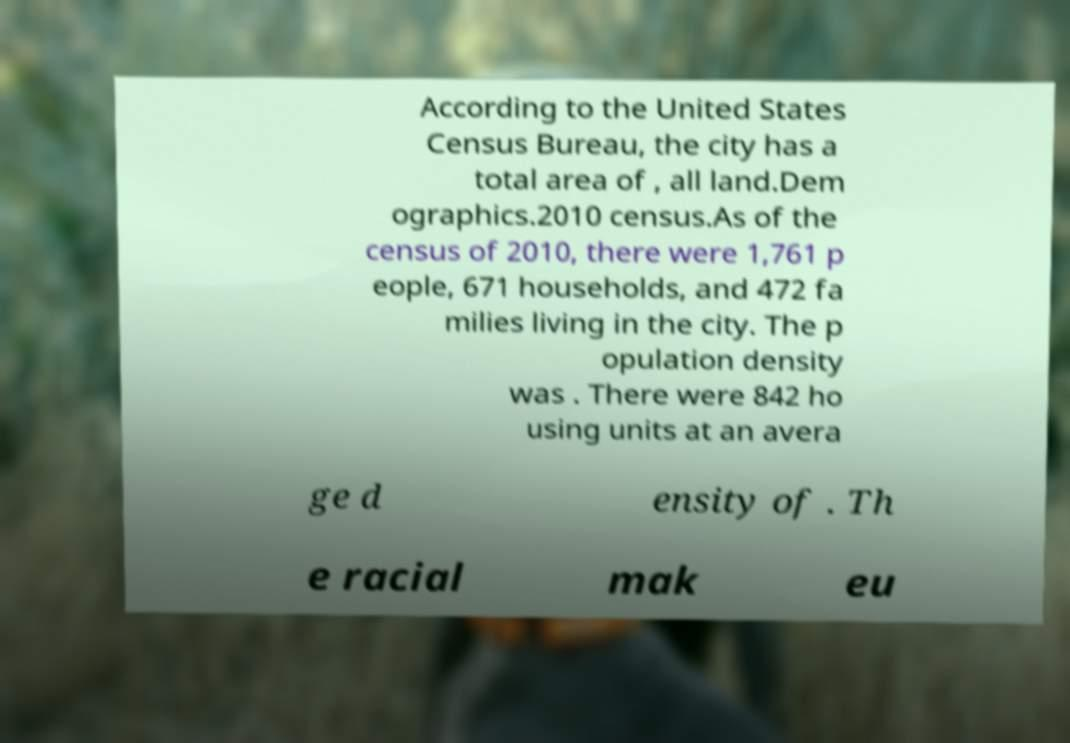Could you extract and type out the text from this image? According to the United States Census Bureau, the city has a total area of , all land.Dem ographics.2010 census.As of the census of 2010, there were 1,761 p eople, 671 households, and 472 fa milies living in the city. The p opulation density was . There were 842 ho using units at an avera ge d ensity of . Th e racial mak eu 